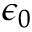Convert formula to latex. <formula><loc_0><loc_0><loc_500><loc_500>\epsilon _ { 0 }</formula> 